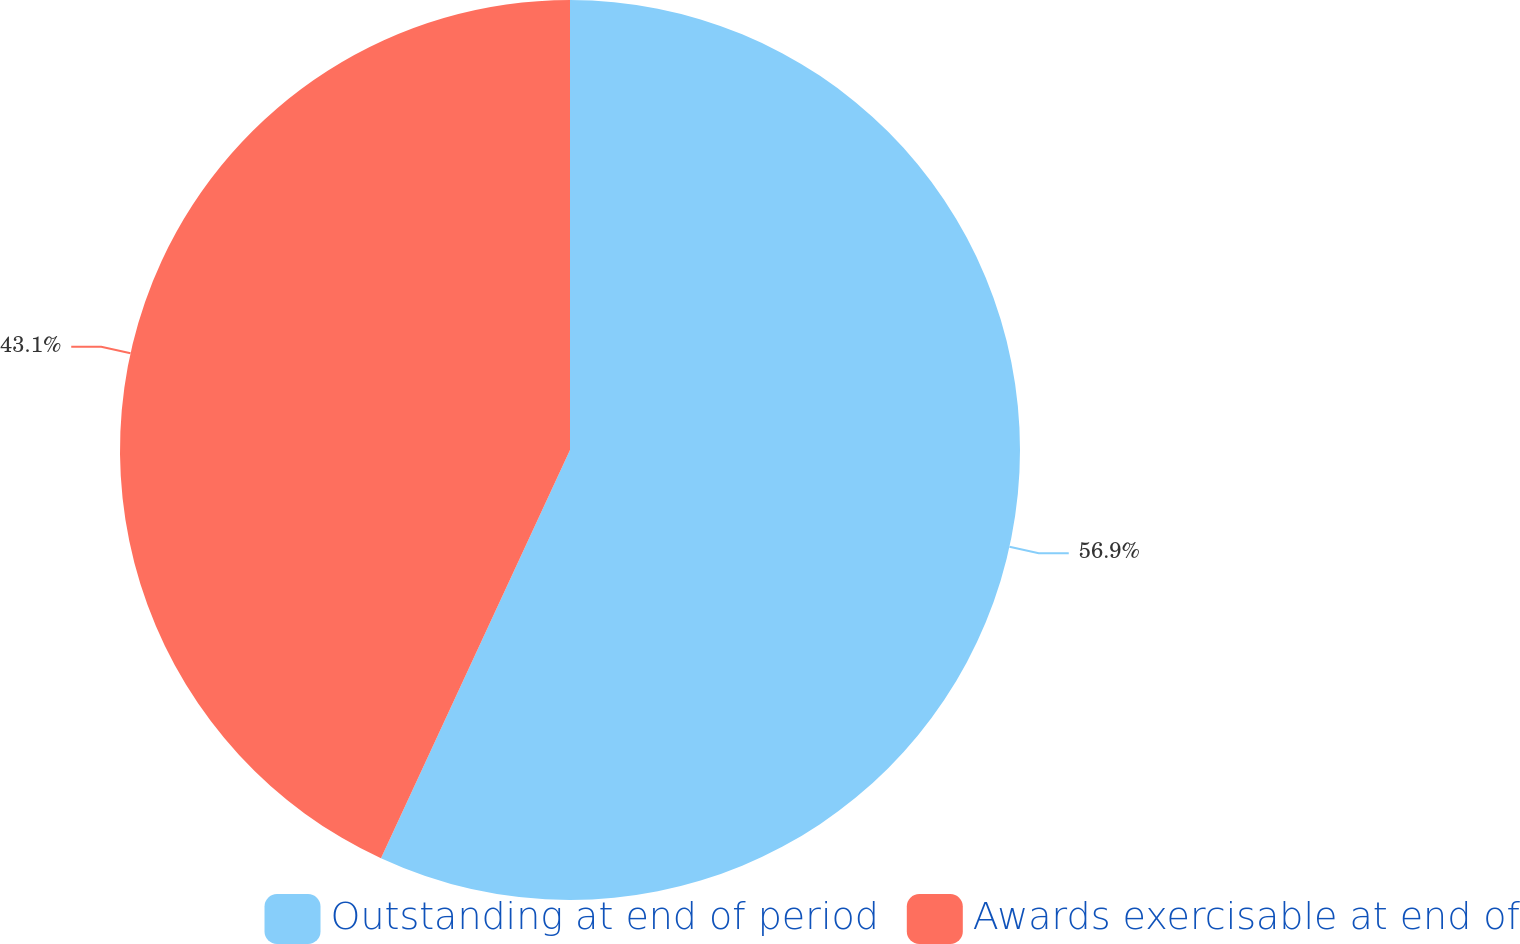<chart> <loc_0><loc_0><loc_500><loc_500><pie_chart><fcel>Outstanding at end of period<fcel>Awards exercisable at end of<nl><fcel>56.9%<fcel>43.1%<nl></chart> 